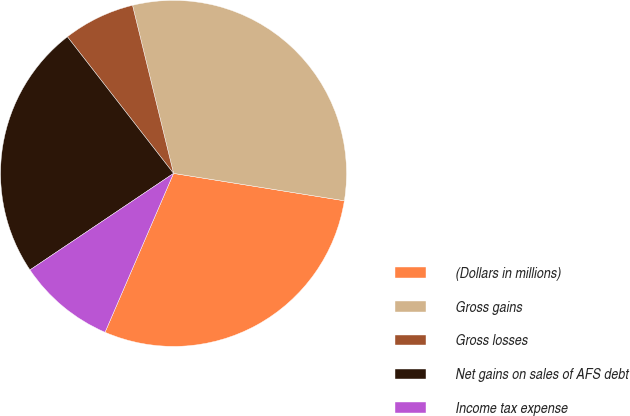Convert chart to OTSL. <chart><loc_0><loc_0><loc_500><loc_500><pie_chart><fcel>(Dollars in millions)<fcel>Gross gains<fcel>Gross losses<fcel>Net gains on sales of AFS debt<fcel>Income tax expense<nl><fcel>28.95%<fcel>31.34%<fcel>6.7%<fcel>23.91%<fcel>9.1%<nl></chart> 